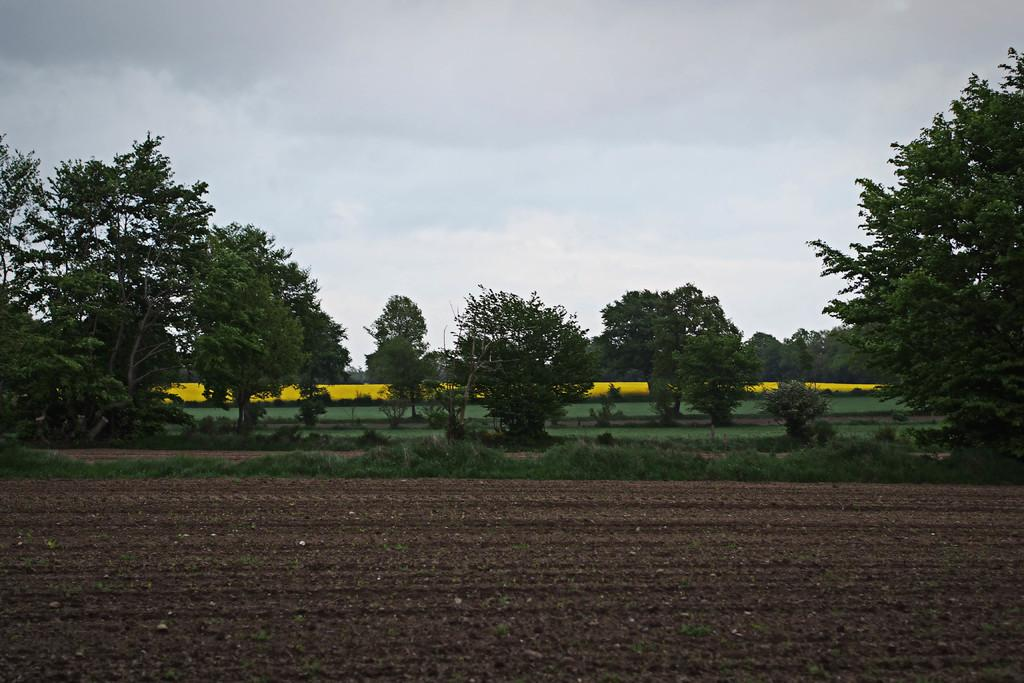What is visible on the ground in the image? The ground is visible in the image. What type of vegetation can be seen in the background of the image? There is grass and trees in the background of the image. What is visible in the sky in the background of the image? Clouds are visible in the sky in the background of the image. Are there any coils visible in the image? There are no coils present in the image. Can you see any dinosaurs in the image? There are no dinosaurs present in the image. 